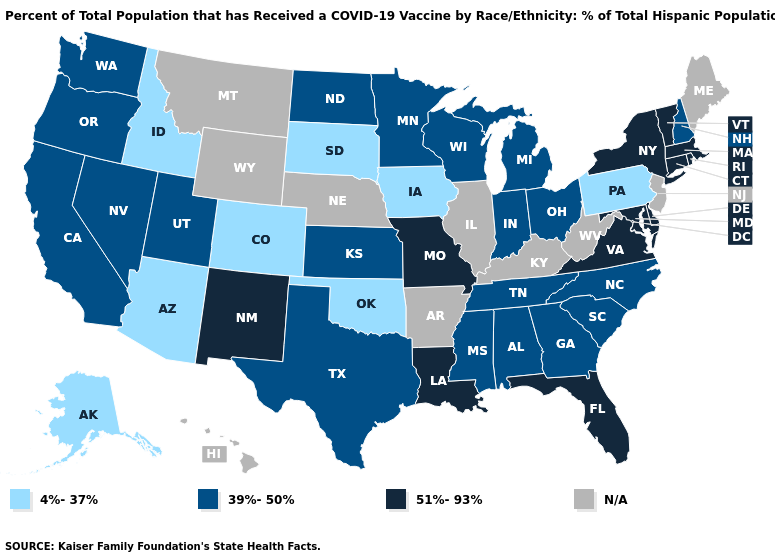Is the legend a continuous bar?
Be succinct. No. Name the states that have a value in the range 39%-50%?
Write a very short answer. Alabama, California, Georgia, Indiana, Kansas, Michigan, Minnesota, Mississippi, Nevada, New Hampshire, North Carolina, North Dakota, Ohio, Oregon, South Carolina, Tennessee, Texas, Utah, Washington, Wisconsin. Does New Mexico have the highest value in the West?
Answer briefly. Yes. What is the highest value in states that border North Dakota?
Answer briefly. 39%-50%. Does the first symbol in the legend represent the smallest category?
Concise answer only. Yes. Is the legend a continuous bar?
Write a very short answer. No. What is the value of Wisconsin?
Give a very brief answer. 39%-50%. What is the highest value in the West ?
Write a very short answer. 51%-93%. Among the states that border South Dakota , does Minnesota have the lowest value?
Short answer required. No. Does Vermont have the highest value in the USA?
Be succinct. Yes. Name the states that have a value in the range 51%-93%?
Concise answer only. Connecticut, Delaware, Florida, Louisiana, Maryland, Massachusetts, Missouri, New Mexico, New York, Rhode Island, Vermont, Virginia. What is the value of Indiana?
Write a very short answer. 39%-50%. What is the highest value in the MidWest ?
Be succinct. 51%-93%. Which states have the highest value in the USA?
Give a very brief answer. Connecticut, Delaware, Florida, Louisiana, Maryland, Massachusetts, Missouri, New Mexico, New York, Rhode Island, Vermont, Virginia. Does California have the lowest value in the West?
Keep it brief. No. 